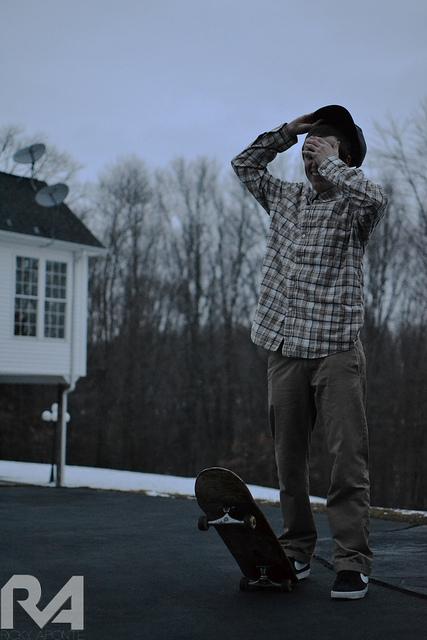Could this be called railing?
Concise answer only. No. Is this guy catching some air?
Write a very short answer. No. What colors the shoes?
Give a very brief answer. Black. How many satellite dishes are on the house?
Concise answer only. 2. How many children are in this image?
Concise answer only. 1. What color are the wheels on the skateboard?
Concise answer only. Black. What is he wearing on his head?
Give a very brief answer. Hat. Does the man featured in the picture have his feet on the ground?
Quick response, please. Yes. Is this a professional athlete?
Quick response, please. No. What is the man's right leg doing?
Be succinct. Holding skateboard. What brand is the shoe?
Concise answer only. Nike. Where would this person be?
Be succinct. Street. What is the person riding?
Short answer required. Skateboard. What is the name of the photography company?
Concise answer only. Ra. Is the board touching the ground?
Answer briefly. Yes. Is he riding downhill?
Short answer required. No. How many stripes are on the boy's shirt?
Answer briefly. Many. Is the skateboarder doing a trick?
Write a very short answer. No. Approximately what time of day is it?
Keep it brief. 7 pm. How is the weather?
Concise answer only. Cloudy with snow on ground. What color is the floor?
Short answer required. Black. How many windows are in the building?
Answer briefly. 2. Where is this?
Short answer required. Outside. Are they airborne?
Keep it brief. No. What time is it?
Write a very short answer. Dusk. What type of footwear is the person wearing?
Short answer required. Sneakers. Are they men or women?
Concise answer only. Men. What is a possible trick the skateboarder could be performing?
Keep it brief. Ollie. What is that skateboard trick called, commonly?
Write a very short answer. Flip. What sport is this?
Be succinct. Skateboarding. Is the person wearing a sweater?
Be succinct. No. What is behind the lady?
Be succinct. Trees. Is the person trying to play tennis?
Keep it brief. No. What color are the boards?
Answer briefly. Black. Do players of this sport usually wear white?
Short answer required. No. Are there leaves on the tree?
Keep it brief. No. What color is the jacket of the man in the middle?
Concise answer only. Plaid. Is this a boy or a girl?
Give a very brief answer. Boy. Is this person going to skate?
Quick response, please. Yes. Does he wear a bow tie?
Answer briefly. No. What is riding a skateboard?
Be succinct. Boy. Is the item the man has his foot on modern or antique?
Write a very short answer. Modern. What is the man doing on the board?
Be succinct. Standing. What type of trees are in the background?
Short answer required. Oak. Is the man standing on a skateboard?
Write a very short answer. Yes. Where is the cap?
Quick response, please. Head. What is in the background?
Keep it brief. Trees. What is the man about to do?
Concise answer only. Skateboard. What is he standing on?
Answer briefly. Skateboard. Where is the owner?
Short answer required. By skateboard. Is the person moving?
Give a very brief answer. No. What is the company name in the logo on the left?
Be succinct. Ra. How old is the kid?
Answer briefly. 16. Is the kid on the board wearing a helmet?
Concise answer only. No. Is the man wearing a hat?
Write a very short answer. Yes. Is he on solid ground?
Quick response, please. Yes. 